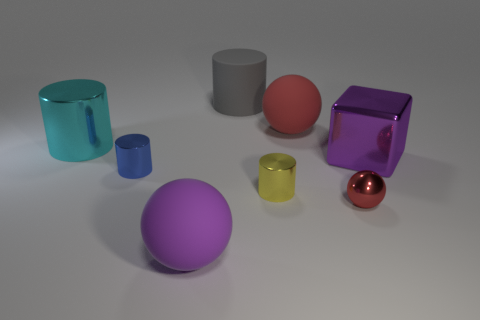Subtract all matte spheres. How many spheres are left? 1 Subtract all purple spheres. How many spheres are left? 2 Subtract all spheres. How many objects are left? 5 Subtract 1 cylinders. How many cylinders are left? 3 Add 1 metallic balls. How many objects exist? 9 Subtract 0 brown spheres. How many objects are left? 8 Subtract all yellow spheres. Subtract all green cylinders. How many spheres are left? 3 Subtract all green spheres. How many yellow cylinders are left? 1 Subtract all balls. Subtract all rubber cylinders. How many objects are left? 4 Add 3 large metal blocks. How many large metal blocks are left? 4 